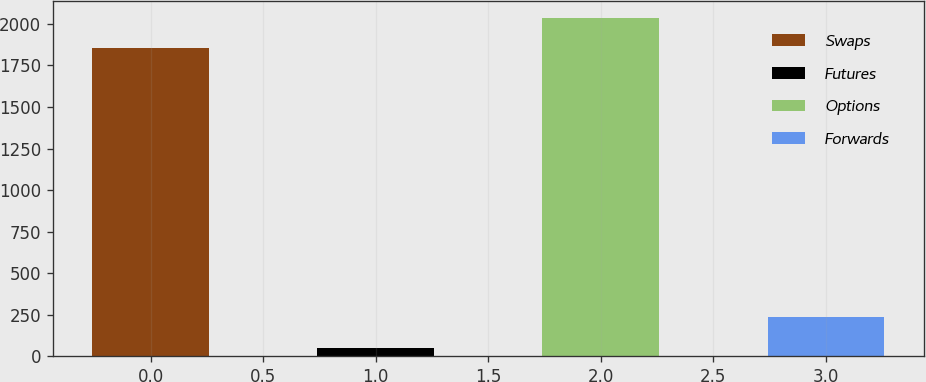Convert chart to OTSL. <chart><loc_0><loc_0><loc_500><loc_500><bar_chart><fcel>Swaps<fcel>Futures<fcel>Options<fcel>Forwards<nl><fcel>1853<fcel>50<fcel>2037.5<fcel>234.5<nl></chart> 